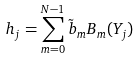Convert formula to latex. <formula><loc_0><loc_0><loc_500><loc_500>h _ { j } = \sum _ { m = 0 } ^ { N - 1 } \tilde { b } _ { m } B _ { m } ( Y _ { j } )</formula> 